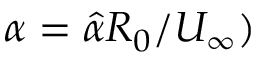<formula> <loc_0><loc_0><loc_500><loc_500>\alpha = \hat { \alpha } R _ { 0 } / U _ { \infty } )</formula> 